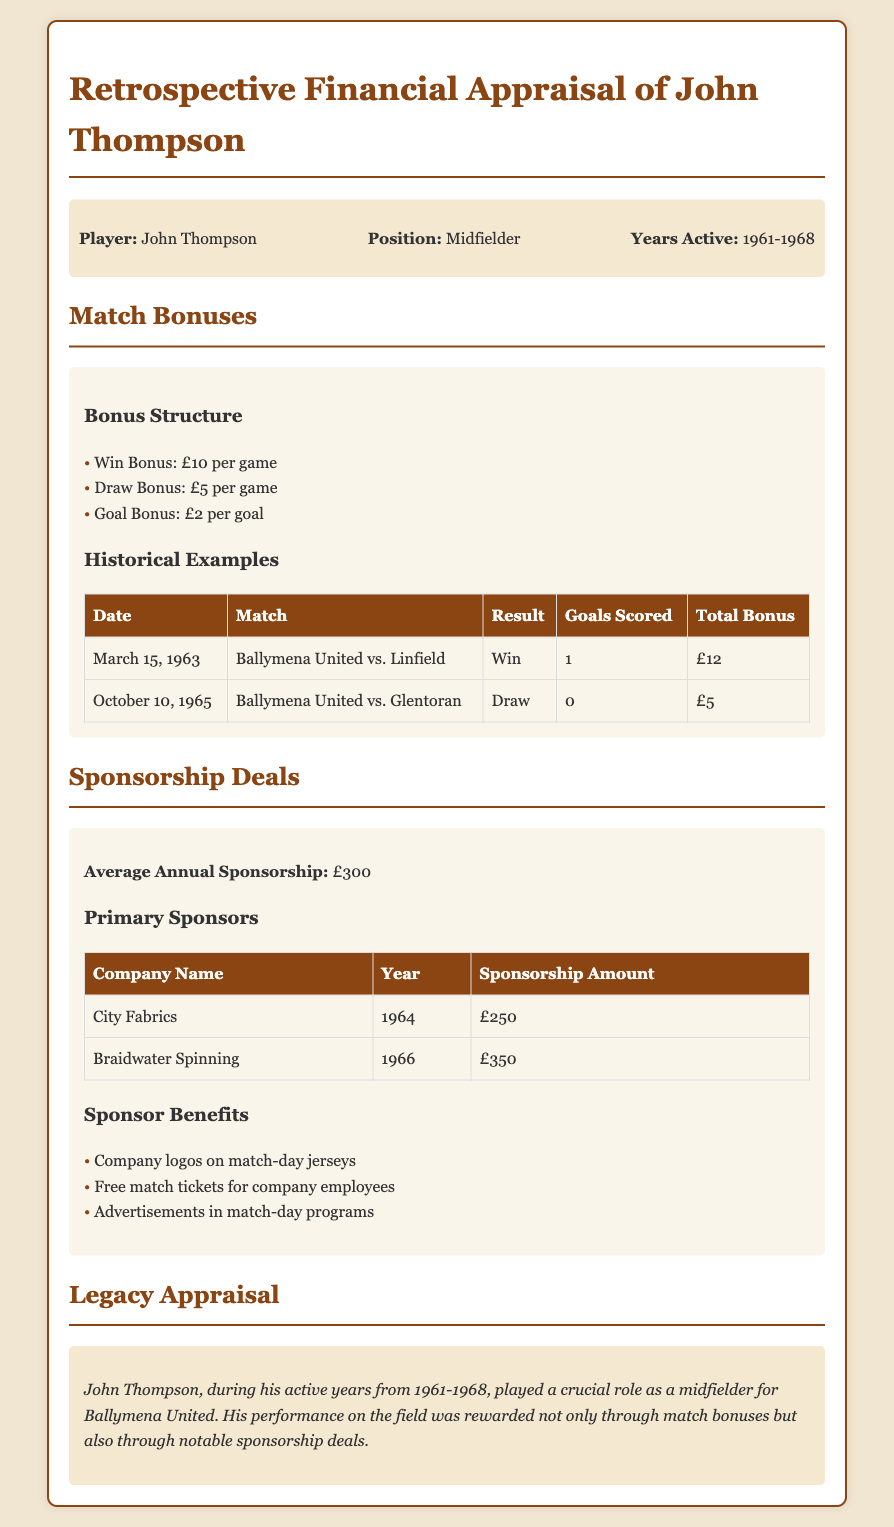What is the player's position? The document specifies John's position as Midfielder.
Answer: Midfielder What was the win bonus per game? According to the bonus structure outlined in the document, the win bonus is £10.
Answer: £10 How many goals were scored in the match on March 15, 1963? The table indicates that 1 goal was scored in the match on this date.
Answer: 1 What was the total bonus for the match against Linfield? The total bonus for that match, as stated in the document, is £12.
Answer: £12 What was the sponsorship amount from Braidwater Spinning? The document lists the sponsorship amount from Braidwater Spinning as £350.
Answer: £350 Which company sponsored Ballymena United in 1964? The document states that City Fabrics was the sponsor in 1964.
Answer: City Fabrics What benefits were provided to sponsors? The document details that one of the benefits was company logos on match-day jerseys.
Answer: Company logos on match-day jerseys What years did John Thompson play for Ballymena United? The document specifies that John Thompson was active from 1961 to 1968.
Answer: 1961-1968 What is the average annual sponsorship amount? The document indicates that the average annual sponsorship is £300.
Answer: £300 